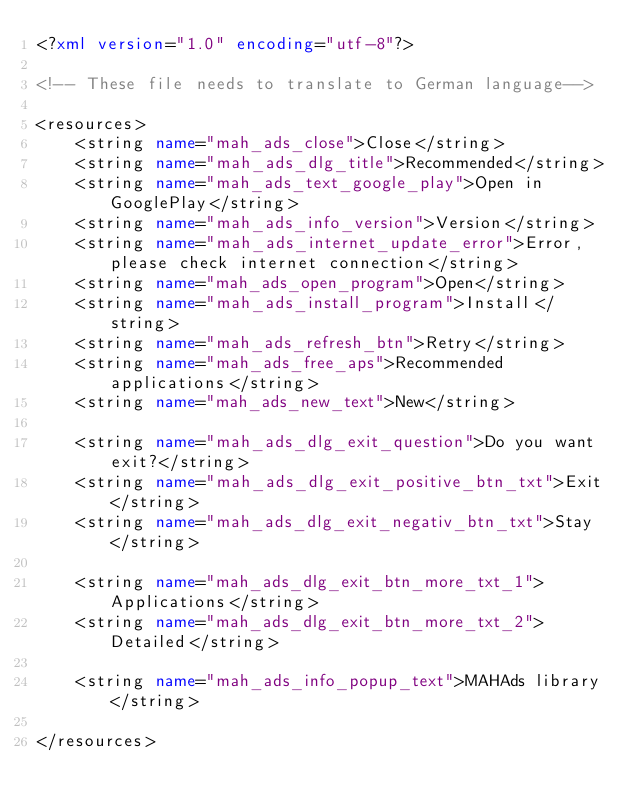<code> <loc_0><loc_0><loc_500><loc_500><_XML_><?xml version="1.0" encoding="utf-8"?>

<!-- These file needs to translate to German language-->

<resources>
    <string name="mah_ads_close">Close</string>
    <string name="mah_ads_dlg_title">Recommended</string>
    <string name="mah_ads_text_google_play">Open in GooglePlay</string>
    <string name="mah_ads_info_version">Version</string>
    <string name="mah_ads_internet_update_error">Error, please check internet connection</string>
    <string name="mah_ads_open_program">Open</string>
    <string name="mah_ads_install_program">Install</string>
    <string name="mah_ads_refresh_btn">Retry</string>
    <string name="mah_ads_free_aps">Recommended applications</string>
    <string name="mah_ads_new_text">New</string>
    
    <string name="mah_ads_dlg_exit_question">Do you want exit?</string>
    <string name="mah_ads_dlg_exit_positive_btn_txt">Exit</string>
    <string name="mah_ads_dlg_exit_negativ_btn_txt">Stay</string>
    
    <string name="mah_ads_dlg_exit_btn_more_txt_1">Applications</string>
    <string name="mah_ads_dlg_exit_btn_more_txt_2">Detailed</string>

    <string name="mah_ads_info_popup_text">MAHAds library</string>

</resources>
</code> 